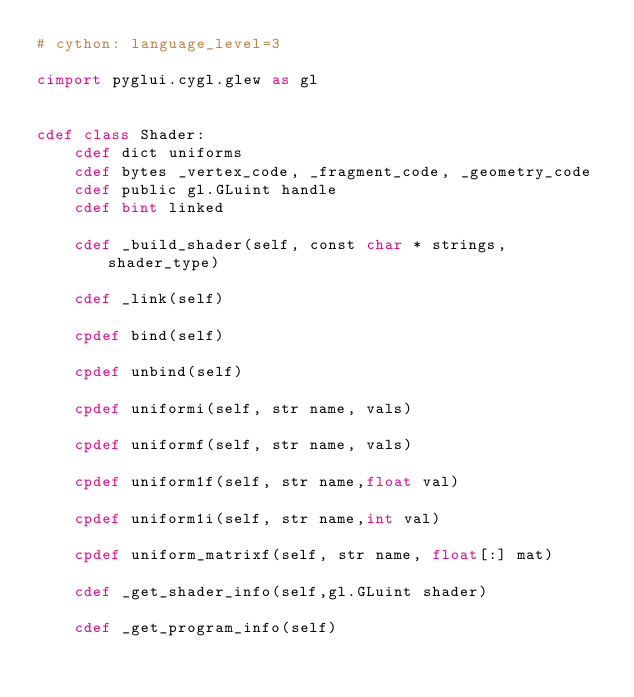<code> <loc_0><loc_0><loc_500><loc_500><_Cython_># cython: language_level=3

cimport pyglui.cygl.glew as gl


cdef class Shader:
    cdef dict uniforms
    cdef bytes _vertex_code, _fragment_code, _geometry_code
    cdef public gl.GLuint handle
    cdef bint linked

    cdef _build_shader(self, const char * strings, shader_type)

    cdef _link(self)

    cpdef bind(self)

    cpdef unbind(self)

    cpdef uniformi(self, str name, vals)

    cpdef uniformf(self, str name, vals)

    cpdef uniform1f(self, str name,float val)

    cpdef uniform1i(self, str name,int val)

    cpdef uniform_matrixf(self, str name, float[:] mat)

    cdef _get_shader_info(self,gl.GLuint shader)

    cdef _get_program_info(self)
</code> 